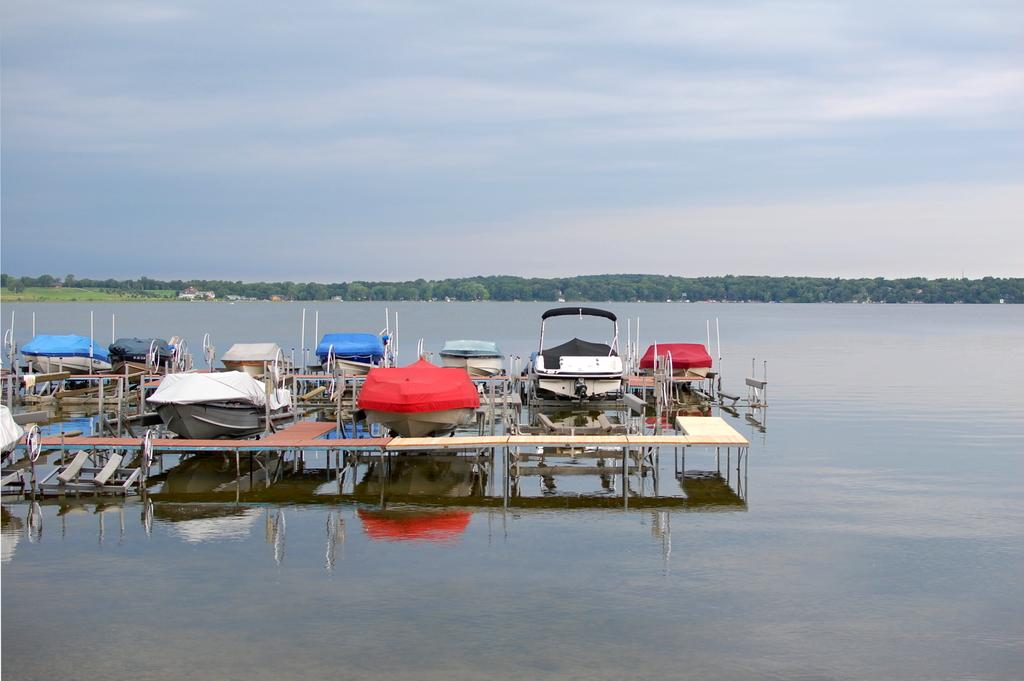What type of vehicles can be seen in the image? There are boats in the image. Where are the boats located in relation to the water? The boats are above the water surface. What can be seen in the background of the image? There are trees in the background of the image. What type of plastic material can be seen covering the boats in the image? There is no plastic material covering the boats in the image; they are above the water surface. How many dogs are visible in the image? There are no dogs present in the image. 